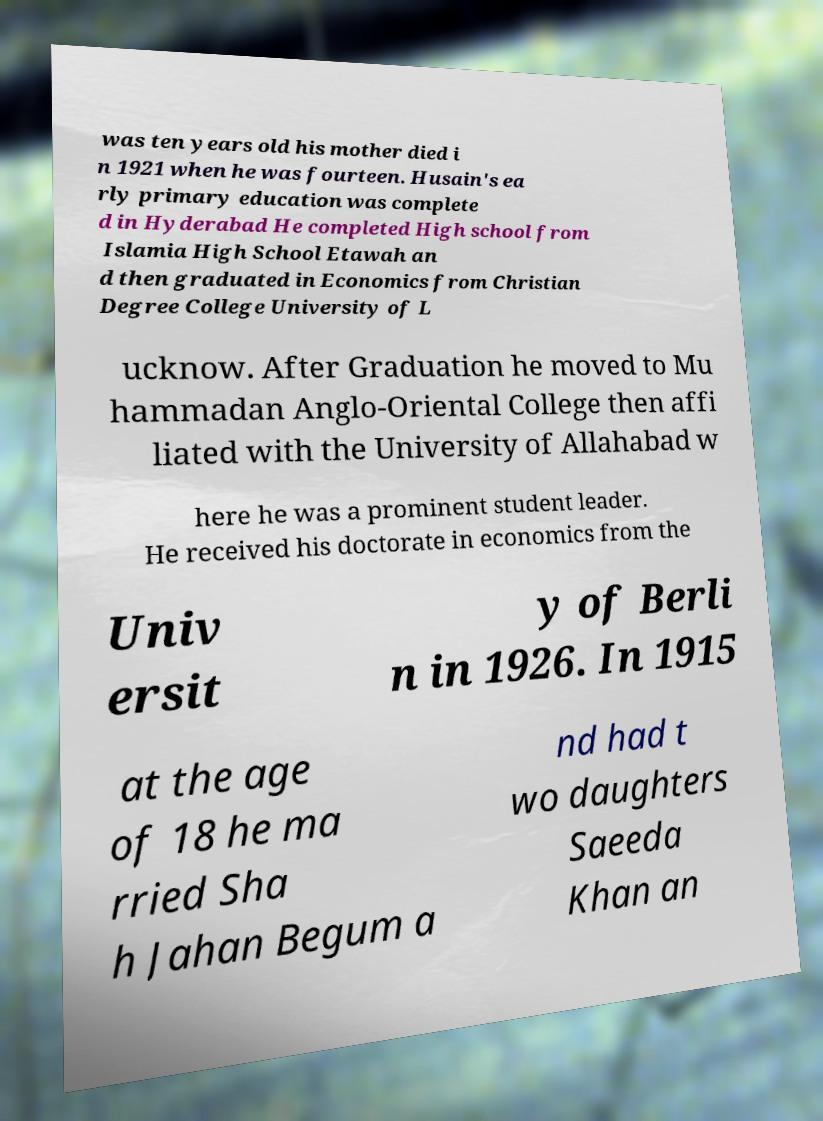What messages or text are displayed in this image? I need them in a readable, typed format. was ten years old his mother died i n 1921 when he was fourteen. Husain's ea rly primary education was complete d in Hyderabad He completed High school from Islamia High School Etawah an d then graduated in Economics from Christian Degree College University of L ucknow. After Graduation he moved to Mu hammadan Anglo-Oriental College then affi liated with the University of Allahabad w here he was a prominent student leader. He received his doctorate in economics from the Univ ersit y of Berli n in 1926. In 1915 at the age of 18 he ma rried Sha h Jahan Begum a nd had t wo daughters Saeeda Khan an 